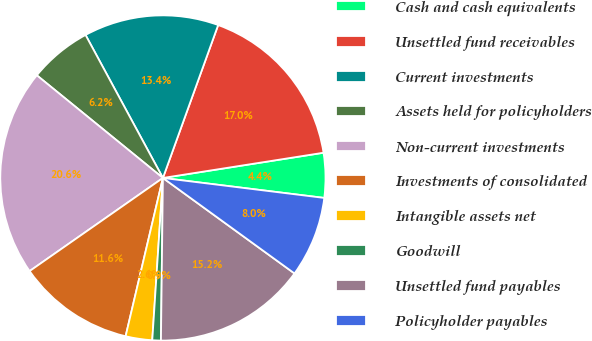<chart> <loc_0><loc_0><loc_500><loc_500><pie_chart><fcel>Cash and cash equivalents<fcel>Unsettled fund receivables<fcel>Current investments<fcel>Assets held for policyholders<fcel>Non-current investments<fcel>Investments of consolidated<fcel>Intangible assets net<fcel>Goodwill<fcel>Unsettled fund payables<fcel>Policyholder payables<nl><fcel>4.44%<fcel>17.0%<fcel>13.41%<fcel>6.23%<fcel>20.58%<fcel>11.61%<fcel>2.64%<fcel>0.85%<fcel>15.2%<fcel>8.03%<nl></chart> 